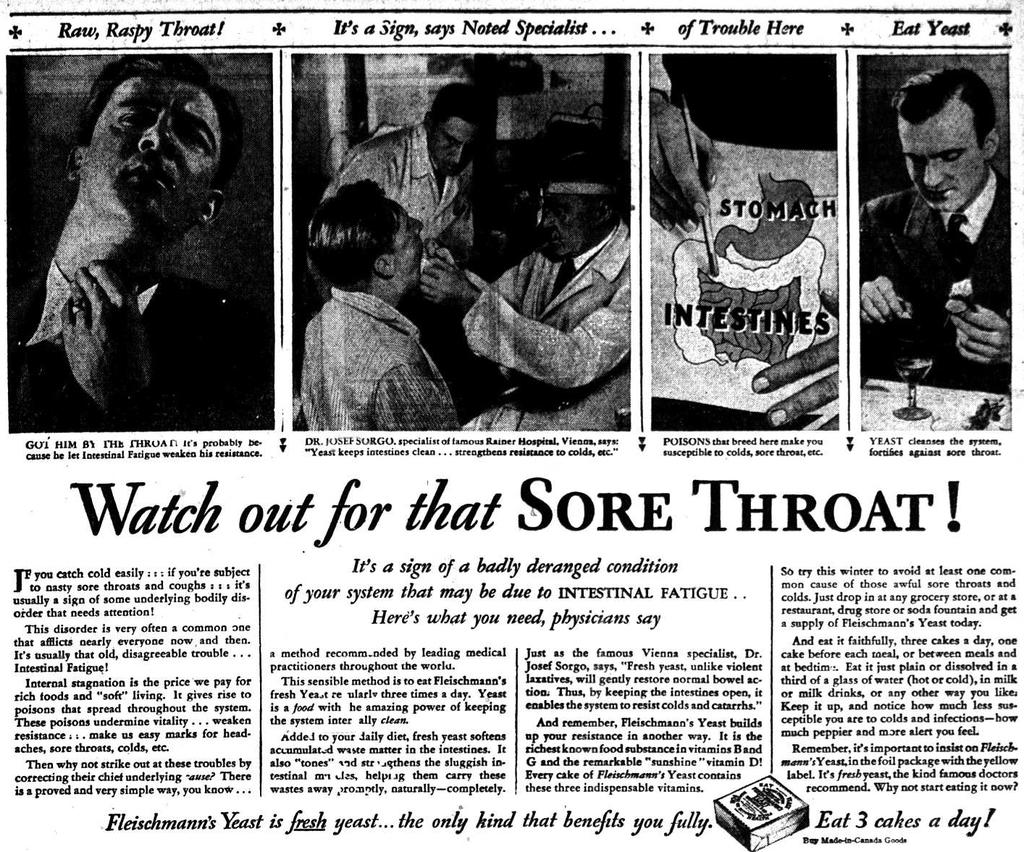What is the main object in the image? There is a poster in the image. What can be seen on the poster? There are people depicted on the poster. Are there any words or phrases on the poster? Yes, there is writing on the poster. What type of drum can be seen in the image? There is no drum present in the image; it only features a poster with people and writing. 